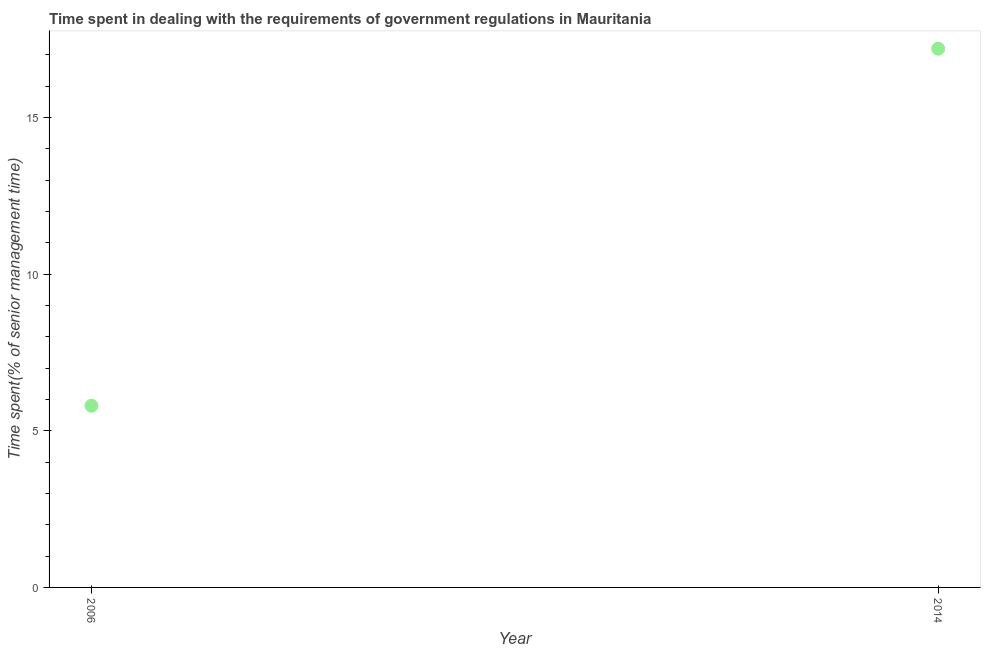What is the time spent in dealing with government regulations in 2006?
Give a very brief answer. 5.8. In which year was the time spent in dealing with government regulations maximum?
Provide a succinct answer. 2014. What is the sum of the time spent in dealing with government regulations?
Your response must be concise. 23. What is the difference between the time spent in dealing with government regulations in 2006 and 2014?
Your answer should be compact. -11.4. What is the average time spent in dealing with government regulations per year?
Offer a very short reply. 11.5. What is the median time spent in dealing with government regulations?
Your response must be concise. 11.5. In how many years, is the time spent in dealing with government regulations greater than 15 %?
Keep it short and to the point. 1. Do a majority of the years between 2006 and 2014 (inclusive) have time spent in dealing with government regulations greater than 15 %?
Keep it short and to the point. No. What is the ratio of the time spent in dealing with government regulations in 2006 to that in 2014?
Your answer should be compact. 0.34. Is the time spent in dealing with government regulations in 2006 less than that in 2014?
Give a very brief answer. Yes. In how many years, is the time spent in dealing with government regulations greater than the average time spent in dealing with government regulations taken over all years?
Make the answer very short. 1. How many years are there in the graph?
Ensure brevity in your answer.  2. Does the graph contain grids?
Your answer should be compact. No. What is the title of the graph?
Give a very brief answer. Time spent in dealing with the requirements of government regulations in Mauritania. What is the label or title of the Y-axis?
Provide a short and direct response. Time spent(% of senior management time). What is the Time spent(% of senior management time) in 2014?
Make the answer very short. 17.2. What is the ratio of the Time spent(% of senior management time) in 2006 to that in 2014?
Your answer should be compact. 0.34. 